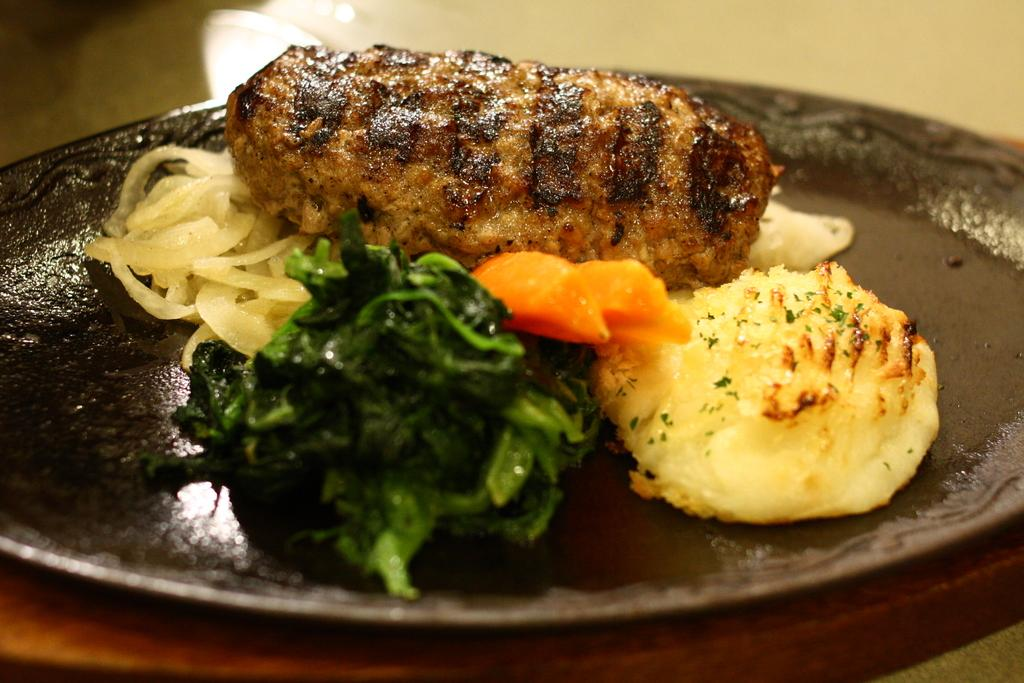What is the color of the plate in the image? There is a black plate in the image. What can be found on the plate? There are different types of food on the plate. Can you describe the colors of the food on the plate? The colors of the food include brown, green, orange, and cream. Is the plate being used by a beginner chef in the image? There is no information about the chef's skill level in the image, so it cannot be determined if they are a beginner or not. 